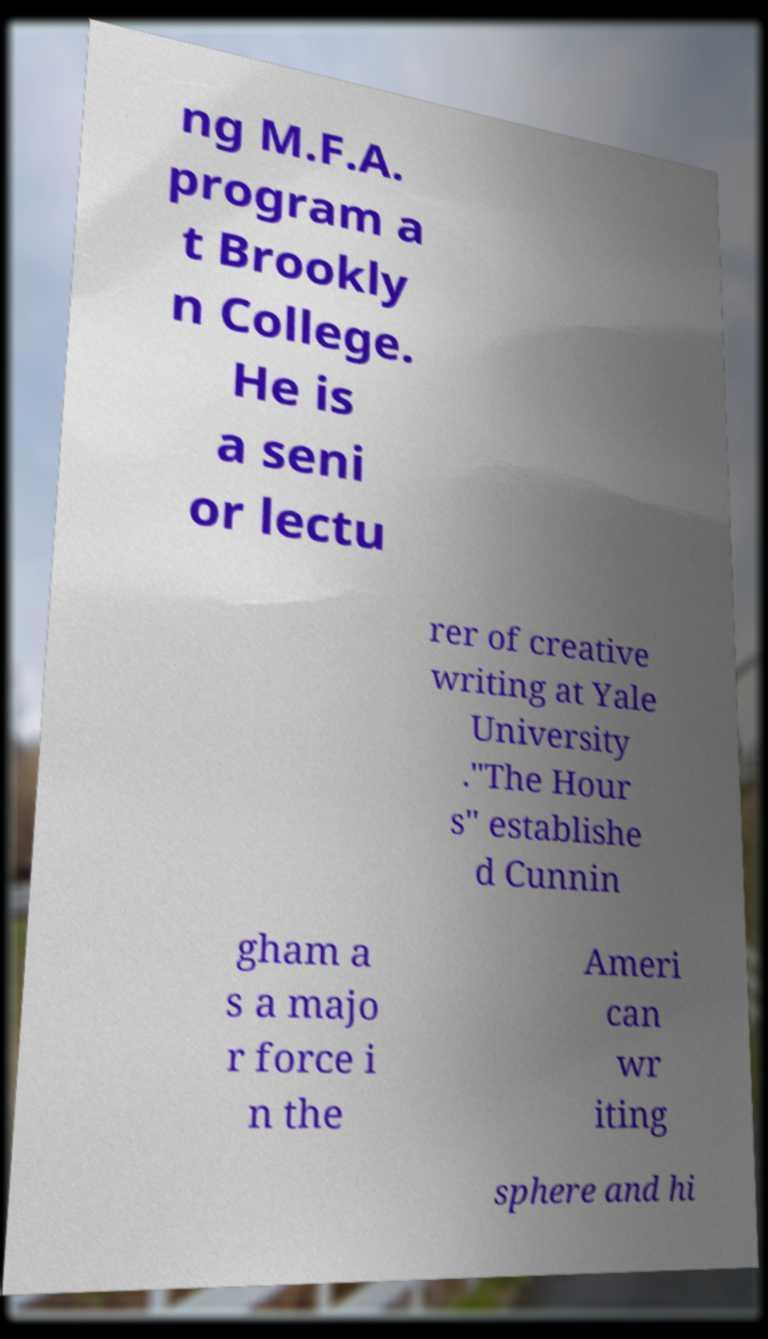Can you read and provide the text displayed in the image?This photo seems to have some interesting text. Can you extract and type it out for me? ng M.F.A. program a t Brookly n College. He is a seni or lectu rer of creative writing at Yale University ."The Hour s" establishe d Cunnin gham a s a majo r force i n the Ameri can wr iting sphere and hi 